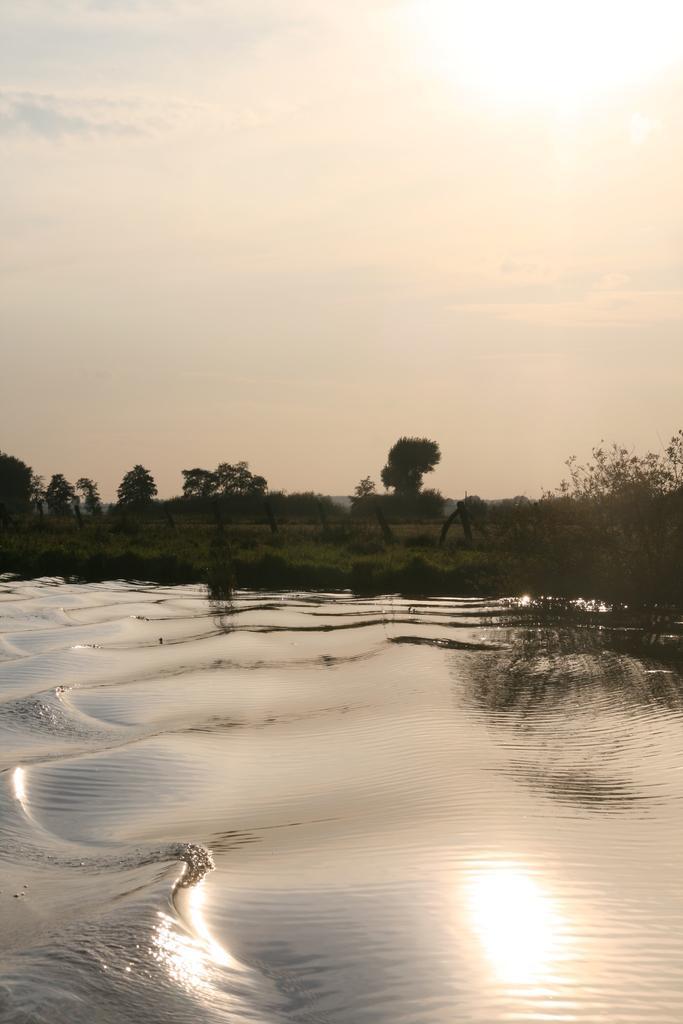In one or two sentences, can you explain what this image depicts? We can see water, grass and trees. In the background we can see sky. 